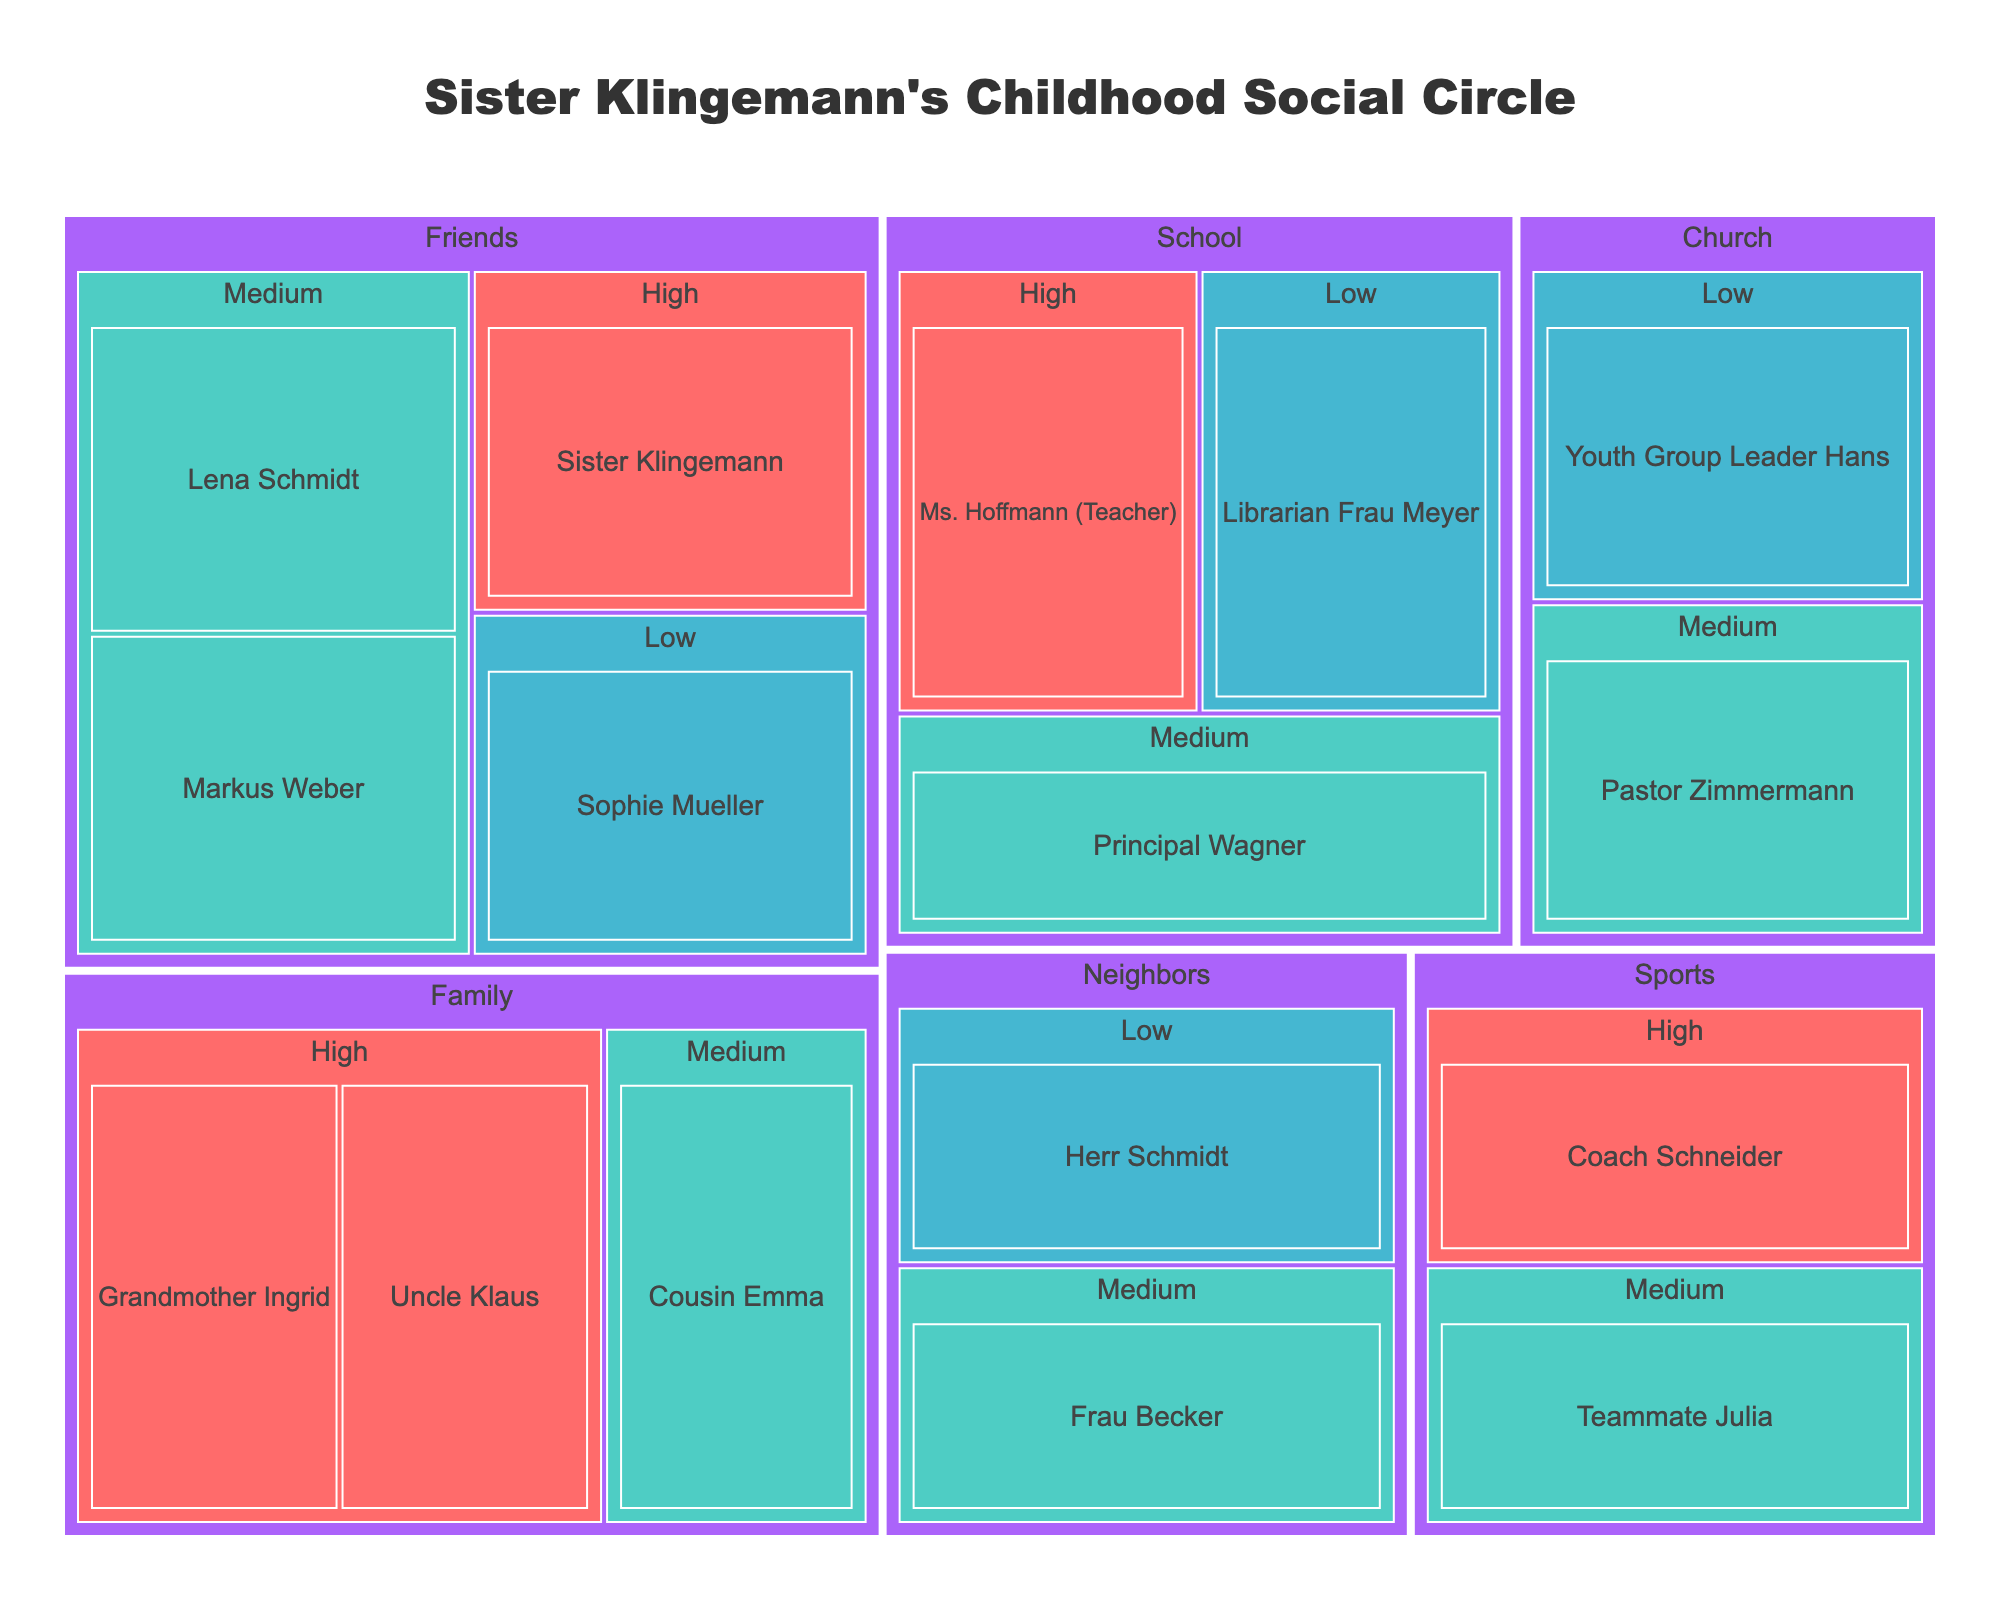What is the title of the treemap? The title is usually at the top of the figure and serves to describe what the treemap illustrates.
Answer: Sister Klingemann's Childhood Social Circle How many relationship types are represented in the treemap? We need to count the number of distinct groups under 'Relationship' in the treemap.
Answer: 5 Who is the person with high influence in the family? The treemap groups persons by relationship types and influence levels, so we look under 'Family' for entries with high influence.
Answer: Grandmother Ingrid, Uncle Klaus Which relationship type has the most persons associated with it? To determine this, we count the total number of persons under each relationship type.
Answer: Friends What is the influence level of Cousin Emma? By locating Cousin Emma in the treemap, we can find her associated influence level.
Answer: Medium How many persons with medium influence are in the school group? We count the number of persons under 'School' who have medium influence.
Answer: 1 (Principal Wagner) Compare the number of people with high influence across different relationship types. We need to identify and count the persons with high influence in each relationship type.
Answer: Family: 2, Friends: 1, School: 1, Sports: 1 What color represents the medium influence level, and how does it compare to the color representing the low influence level? By identifying the color used for medium influence and comparing it to the color used for low influence.
Answer: Medium: Green (#4ECDC4), Low: Blue (#45B7D1) Identify the least influential person in the friends group. Find the person with low influence under the 'Friends' relationship type.
Answer: Sophie Mueller 